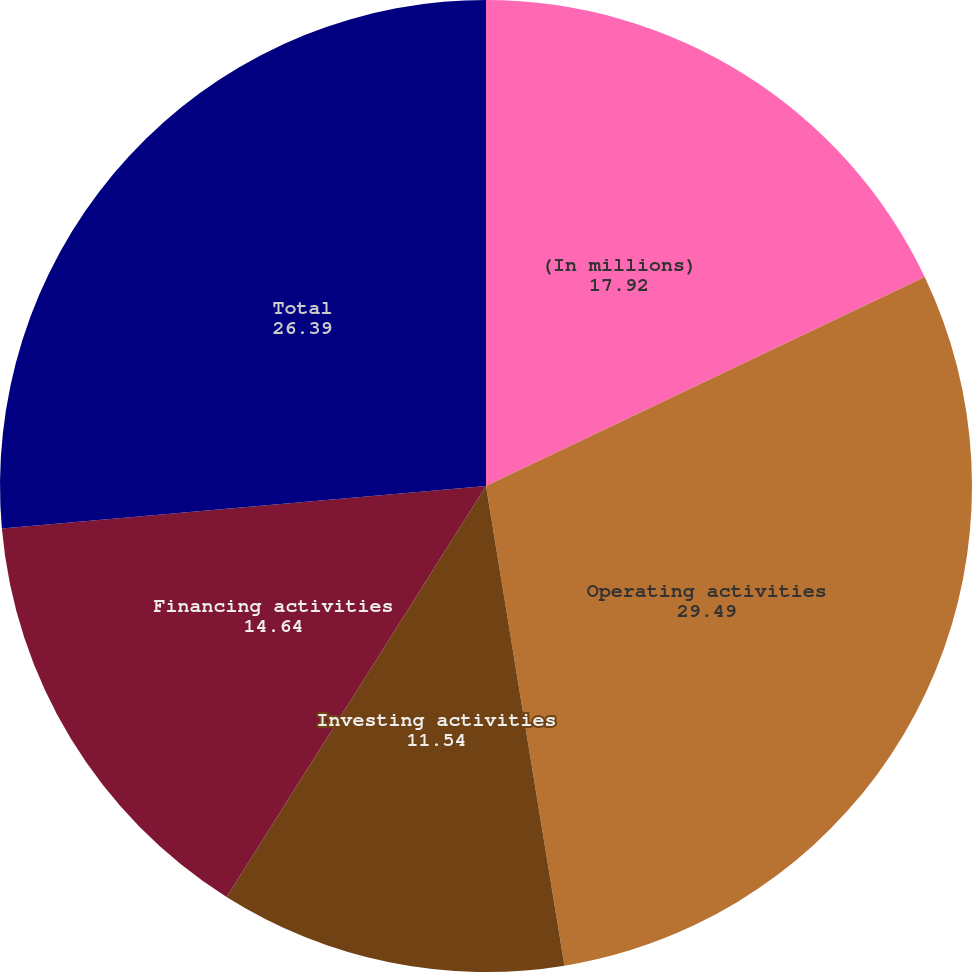Convert chart to OTSL. <chart><loc_0><loc_0><loc_500><loc_500><pie_chart><fcel>(In millions)<fcel>Operating activities<fcel>Investing activities<fcel>Financing activities<fcel>Total<nl><fcel>17.92%<fcel>29.49%<fcel>11.54%<fcel>14.64%<fcel>26.39%<nl></chart> 